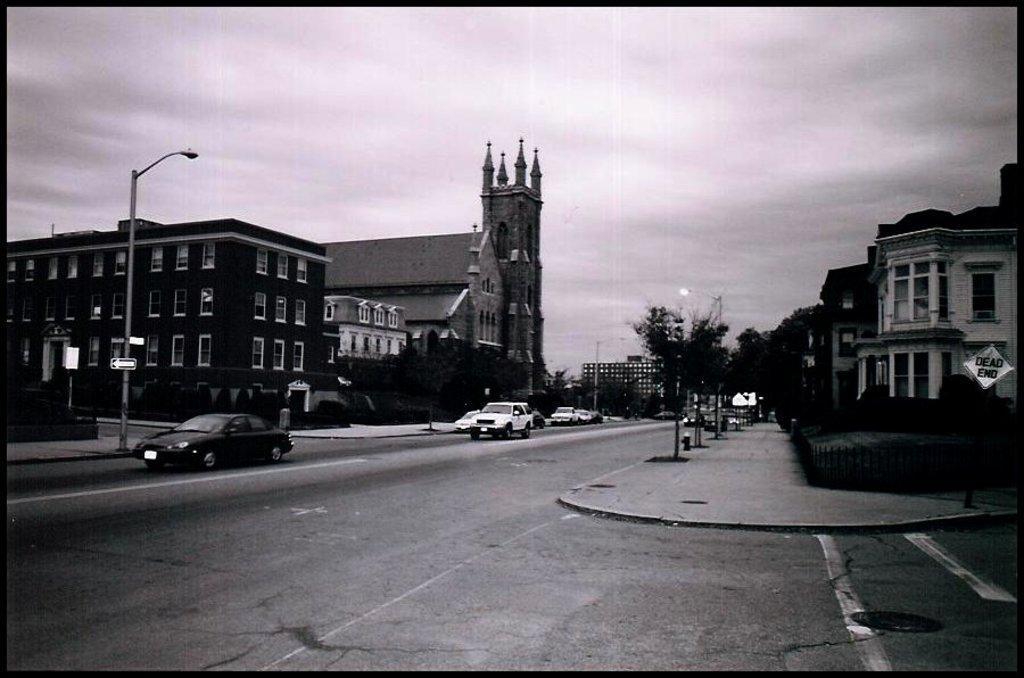How would you summarize this image in a sentence or two? In this image I can see a road, on the road I can see vehicles, beside the road I can see buildings in the middle there are some trees , at the top there is the sky and there are some street lights poles visible beside the road. 